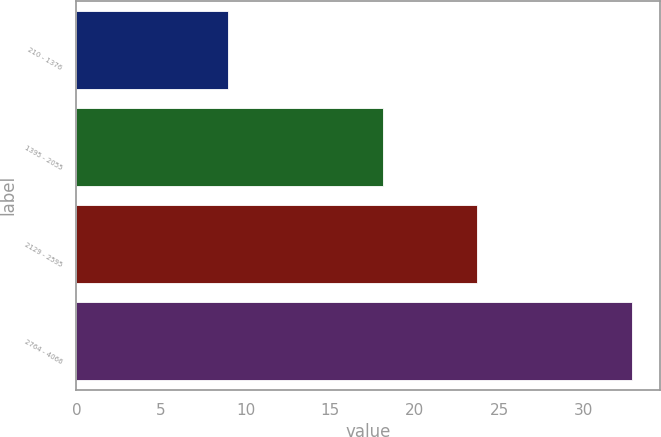<chart> <loc_0><loc_0><loc_500><loc_500><bar_chart><fcel>210 - 1376<fcel>1395 - 2055<fcel>2129 - 2595<fcel>2764 - 4066<nl><fcel>8.97<fcel>18.11<fcel>23.7<fcel>32.85<nl></chart> 